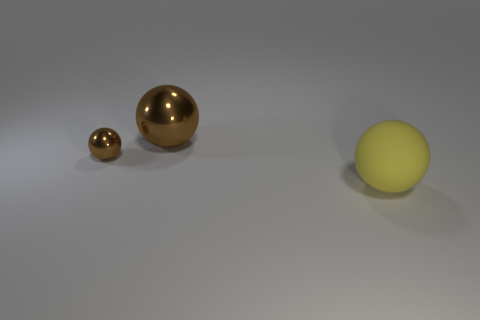Add 2 large brown objects. How many objects exist? 5 Subtract all brown things. Subtract all yellow spheres. How many objects are left? 0 Add 1 small brown metal things. How many small brown metal things are left? 2 Add 3 big green shiny cylinders. How many big green shiny cylinders exist? 3 Subtract 0 blue spheres. How many objects are left? 3 